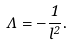<formula> <loc_0><loc_0><loc_500><loc_500>\Lambda = - \frac { 1 } { l ^ { 2 } } .</formula> 